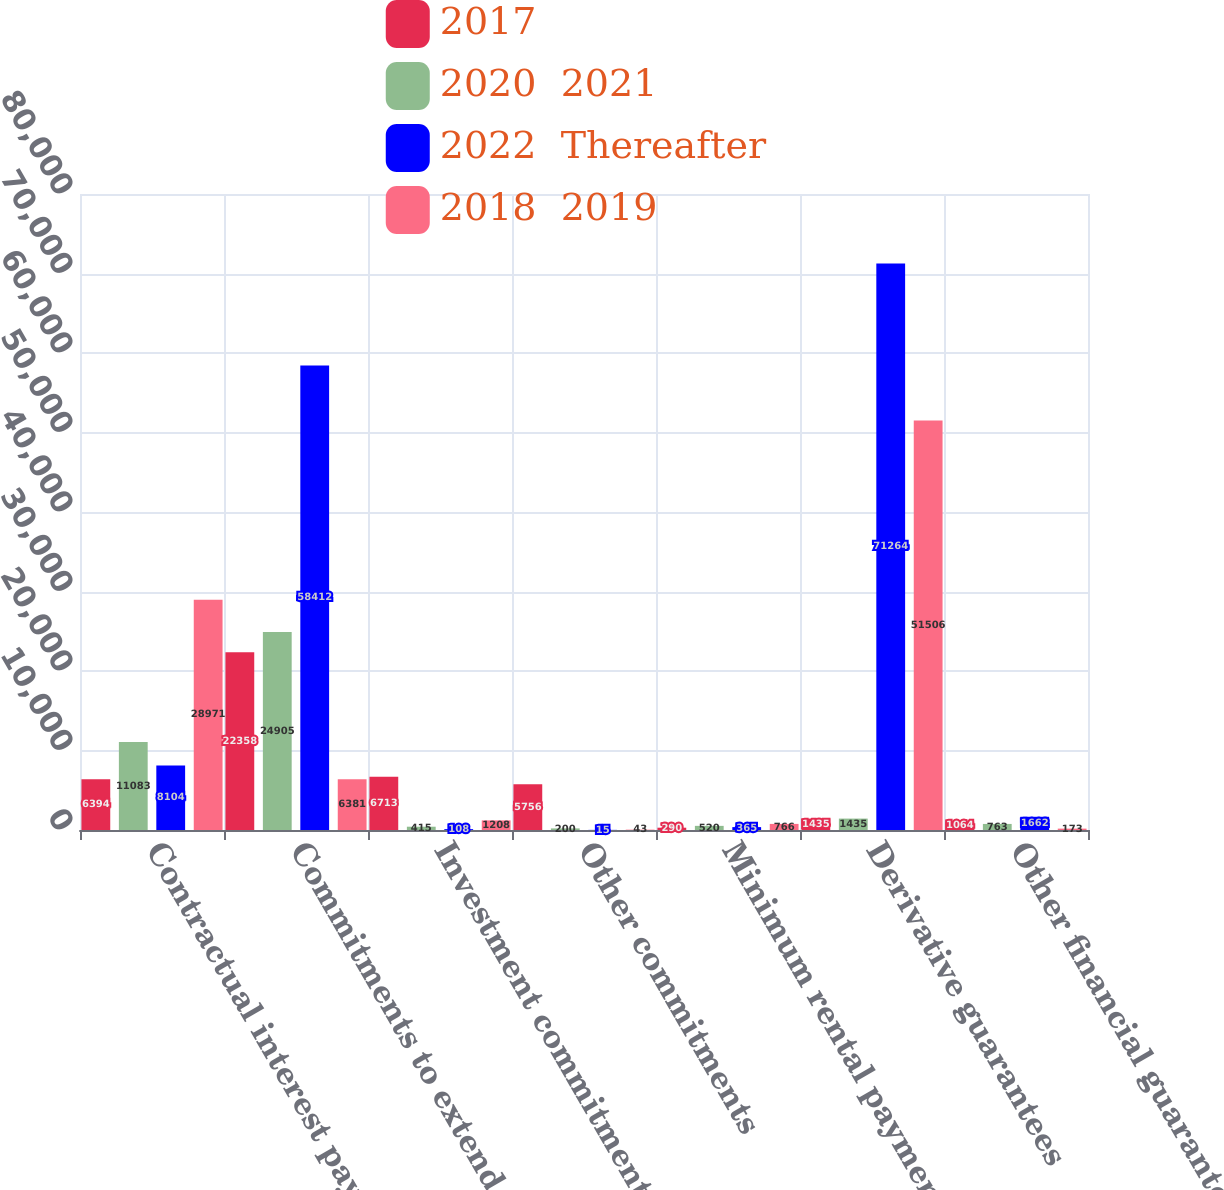Convert chart. <chart><loc_0><loc_0><loc_500><loc_500><stacked_bar_chart><ecel><fcel>Contractual interest payments<fcel>Commitments to extend credit<fcel>Investment commitments<fcel>Other commitments<fcel>Minimum rental payments<fcel>Derivative guarantees<fcel>Other financial guarantees<nl><fcel>2017<fcel>6394<fcel>22358<fcel>6713<fcel>5756<fcel>290<fcel>1435<fcel>1064<nl><fcel>2020  2021<fcel>11083<fcel>24905<fcel>415<fcel>200<fcel>520<fcel>1435<fcel>763<nl><fcel>2022  Thereafter<fcel>8104<fcel>58412<fcel>108<fcel>15<fcel>365<fcel>71264<fcel>1662<nl><fcel>2018  2019<fcel>28971<fcel>6381<fcel>1208<fcel>43<fcel>766<fcel>51506<fcel>173<nl></chart> 